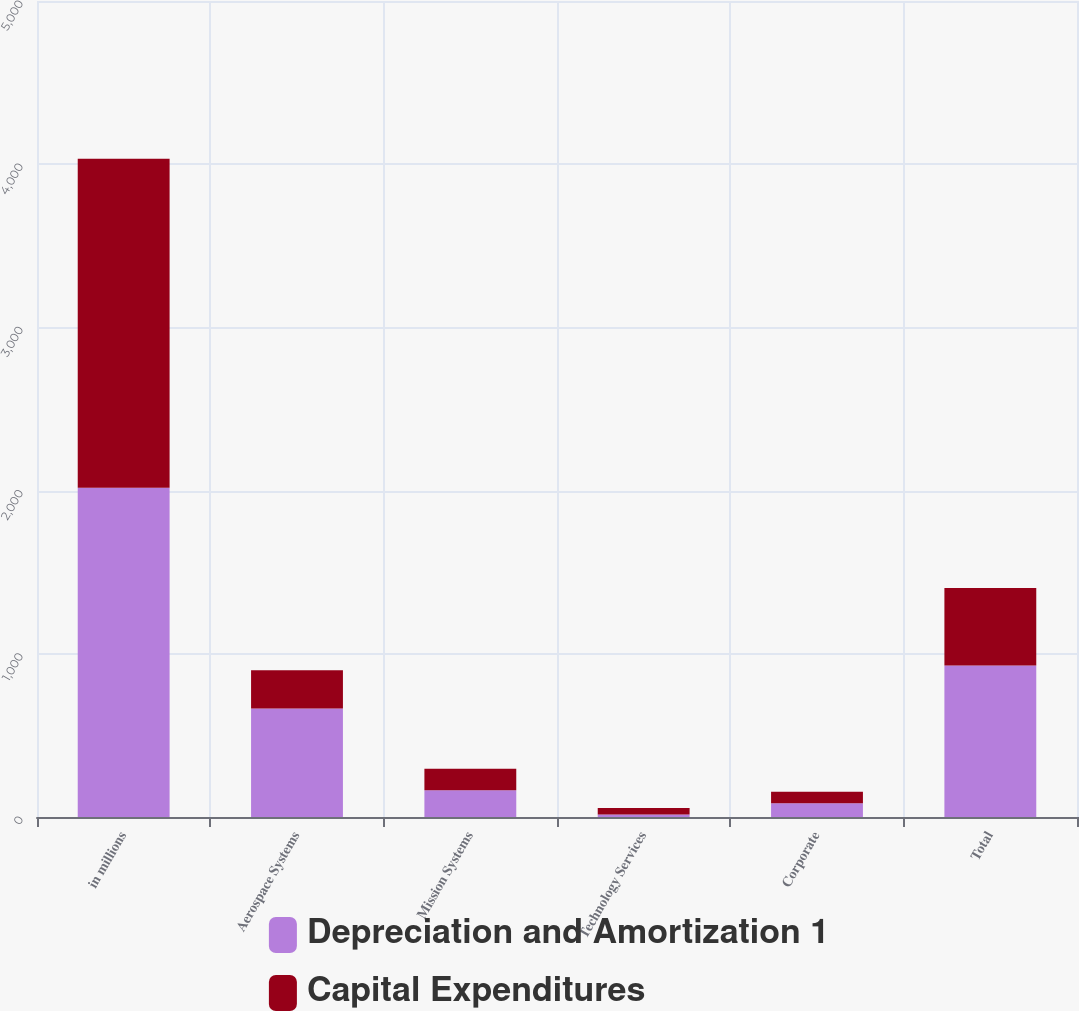Convert chart to OTSL. <chart><loc_0><loc_0><loc_500><loc_500><stacked_bar_chart><ecel><fcel>in millions<fcel>Aerospace Systems<fcel>Mission Systems<fcel>Technology Services<fcel>Corporate<fcel>Total<nl><fcel>Depreciation and Amortization 1<fcel>2017<fcel>665<fcel>164<fcel>15<fcel>84<fcel>928<nl><fcel>Capital Expenditures<fcel>2017<fcel>234<fcel>131<fcel>40<fcel>70<fcel>475<nl></chart> 